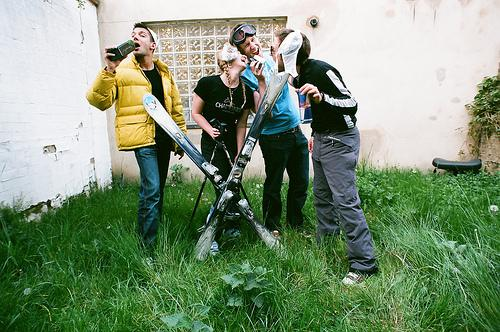Question: where are the skis?
Choices:
A. In the grass.
B. On the mountain.
C. On the ski lift.
D. On top of the car.
Answer with the letter. Answer: A Question: who is behind the skis?
Choices:
A. A man.
B. A lady in a red hat.
C. The boy and girl.
D. A dog.
Answer with the letter. Answer: C Question: what color are the walls?
Choices:
A. White.
B. Blue.
C. Green.
D. Red.
Answer with the letter. Answer: A Question: when was this photo taken?
Choices:
A. At night.
B. In the morning.
C. During the day.
D. In the evening.
Answer with the letter. Answer: C 